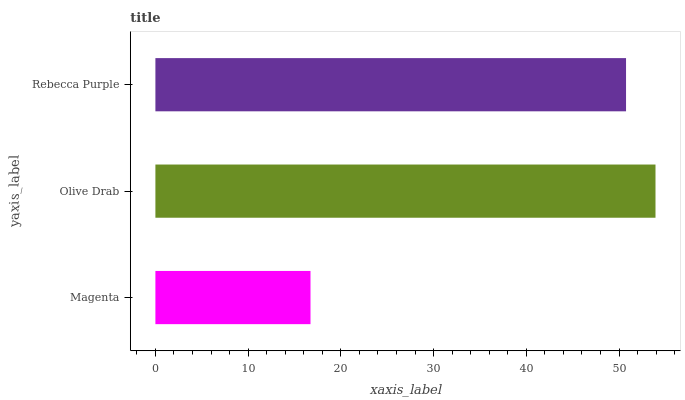Is Magenta the minimum?
Answer yes or no. Yes. Is Olive Drab the maximum?
Answer yes or no. Yes. Is Rebecca Purple the minimum?
Answer yes or no. No. Is Rebecca Purple the maximum?
Answer yes or no. No. Is Olive Drab greater than Rebecca Purple?
Answer yes or no. Yes. Is Rebecca Purple less than Olive Drab?
Answer yes or no. Yes. Is Rebecca Purple greater than Olive Drab?
Answer yes or no. No. Is Olive Drab less than Rebecca Purple?
Answer yes or no. No. Is Rebecca Purple the high median?
Answer yes or no. Yes. Is Rebecca Purple the low median?
Answer yes or no. Yes. Is Olive Drab the high median?
Answer yes or no. No. Is Olive Drab the low median?
Answer yes or no. No. 